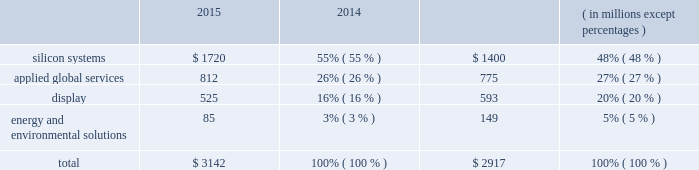Backlog applied manufactures systems to meet demand represented by order backlog and customer commitments .
Backlog consists of : ( 1 ) orders for which written authorizations have been accepted and assigned shipment dates are within the next 12 months , or shipment has occurred but revenue has not been recognized ; and ( 2 ) contractual service revenue and maintenance fees to be earned within the next 12 months .
Backlog by reportable segment as of october 25 , 2015 and october 26 , 2014 was as follows : 2015 2014 ( in millions , except percentages ) .
Applied 2019s backlog on any particular date is not necessarily indicative of actual sales for any future periods , due to the potential for customer changes in delivery schedules or order cancellations .
Customers may delay delivery of products or cancel orders prior to shipment , subject to possible cancellation penalties .
Delays in delivery schedules or a reduction of backlog during any particular period could have a material adverse effect on applied 2019s business and results of operations .
Manufacturing , raw materials and supplies applied 2019s manufacturing activities consist primarily of assembly , test and integration of various proprietary and commercial parts , components and subassemblies that are used to manufacture systems .
Applied has implemented a distributed manufacturing model under which manufacturing and supply chain activities are conducted in various countries , including germany , israel , italy , singapore , taiwan , the united states and other countries in asia .
Applied uses numerous vendors , including contract manufacturers , to supply parts and assembly services for the manufacture and support of its products , including some systems being completed at customer sites .
Although applied makes reasonable efforts to assure that parts are available from multiple qualified suppliers , this is not always possible .
Accordingly , some key parts may be obtained from only a single supplier or a limited group of suppliers .
Applied seeks to reduce costs and to lower the risks of manufacturing and service interruptions by selecting and qualifying alternate suppliers for key parts ; monitoring the financial condition of key suppliers ; maintaining appropriate inventories of key parts ; qualifying new parts on a timely basis ; and ensuring quality and performance of parts. .
What is the growth rate in silicon systems from 2014 to 2015? 
Computations: ((1720 - 1400) / 1400)
Answer: 0.22857. 